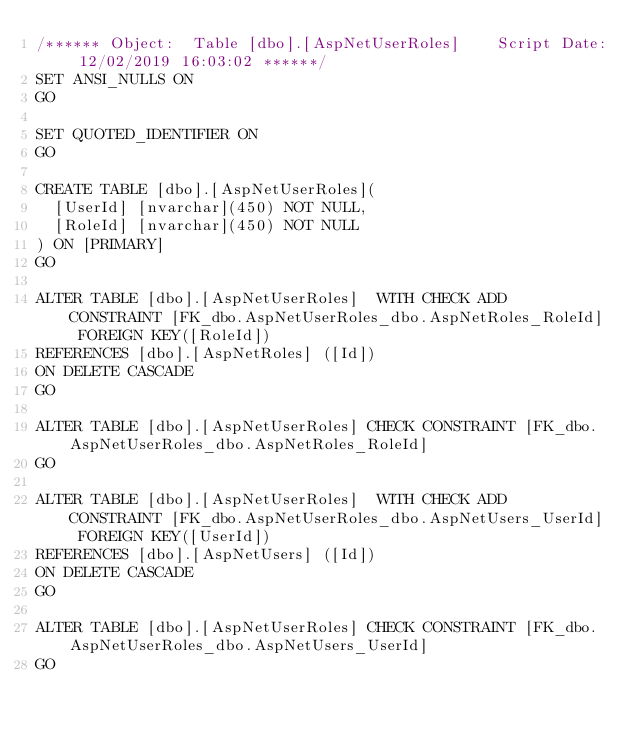<code> <loc_0><loc_0><loc_500><loc_500><_SQL_>/****** Object:  Table [dbo].[AspNetUserRoles]    Script Date: 12/02/2019 16:03:02 ******/
SET ANSI_NULLS ON
GO

SET QUOTED_IDENTIFIER ON
GO

CREATE TABLE [dbo].[AspNetUserRoles](
	[UserId] [nvarchar](450) NOT NULL,
	[RoleId] [nvarchar](450) NOT NULL
) ON [PRIMARY]
GO

ALTER TABLE [dbo].[AspNetUserRoles]  WITH CHECK ADD  CONSTRAINT [FK_dbo.AspNetUserRoles_dbo.AspNetRoles_RoleId] FOREIGN KEY([RoleId])
REFERENCES [dbo].[AspNetRoles] ([Id])
ON DELETE CASCADE
GO

ALTER TABLE [dbo].[AspNetUserRoles] CHECK CONSTRAINT [FK_dbo.AspNetUserRoles_dbo.AspNetRoles_RoleId]
GO

ALTER TABLE [dbo].[AspNetUserRoles]  WITH CHECK ADD  CONSTRAINT [FK_dbo.AspNetUserRoles_dbo.AspNetUsers_UserId] FOREIGN KEY([UserId])
REFERENCES [dbo].[AspNetUsers] ([Id])
ON DELETE CASCADE
GO

ALTER TABLE [dbo].[AspNetUserRoles] CHECK CONSTRAINT [FK_dbo.AspNetUserRoles_dbo.AspNetUsers_UserId]
GO


</code> 